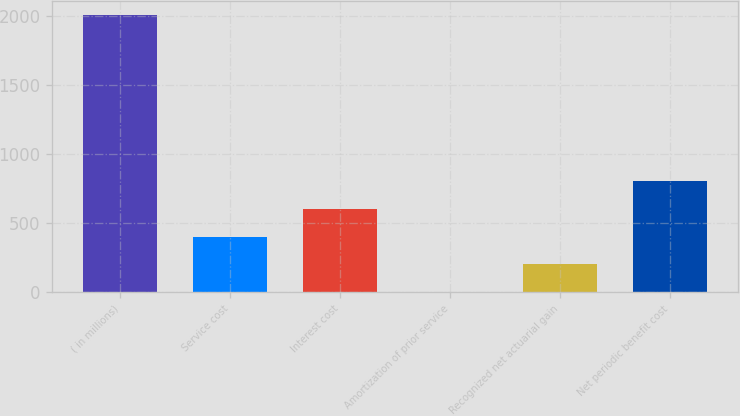Convert chart. <chart><loc_0><loc_0><loc_500><loc_500><bar_chart><fcel>( in millions)<fcel>Service cost<fcel>Interest cost<fcel>Amortization of prior service<fcel>Recognized net actuarial gain<fcel>Net periodic benefit cost<nl><fcel>2008<fcel>401.84<fcel>602.61<fcel>0.3<fcel>201.07<fcel>803.38<nl></chart> 